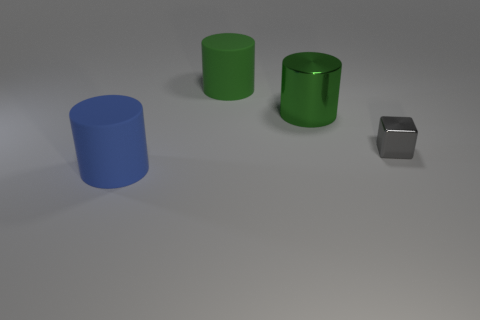Are there any other things that are the same size as the gray shiny object?
Keep it short and to the point. No. Is there anything else that is the same shape as the gray shiny thing?
Offer a very short reply. No. There is a green thing behind the large cylinder right of the big matte cylinder that is behind the small gray metallic block; what is its shape?
Provide a short and direct response. Cylinder. The green matte cylinder has what size?
Keep it short and to the point. Large. Is there a red cylinder made of the same material as the tiny gray cube?
Keep it short and to the point. No. There is another green thing that is the same shape as the big metal thing; what is its size?
Your response must be concise. Large. Are there the same number of large green things to the left of the big blue object and gray metallic blocks?
Keep it short and to the point. No. There is a object that is behind the large green shiny thing; is it the same shape as the large blue thing?
Your answer should be very brief. Yes. The green matte thing is what shape?
Your answer should be compact. Cylinder. What is the material of the big object that is left of the big rubber thing that is to the right of the big blue matte thing in front of the tiny gray thing?
Your response must be concise. Rubber. 